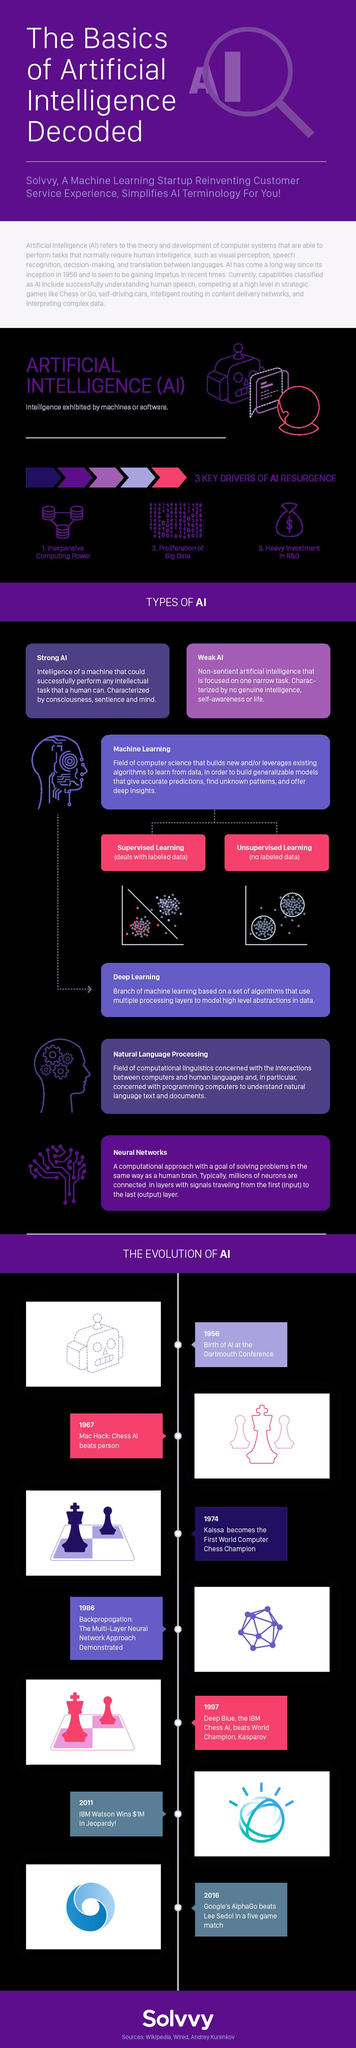Outline some significant characteristics in this image. The key drivers of AI resurgence are inexpensive computing power, the proliferation of big data, and heavy investment in research and development. There are two types of AI mentioned in this infographic. There are two types of machine learning mentioned in this infographic. 